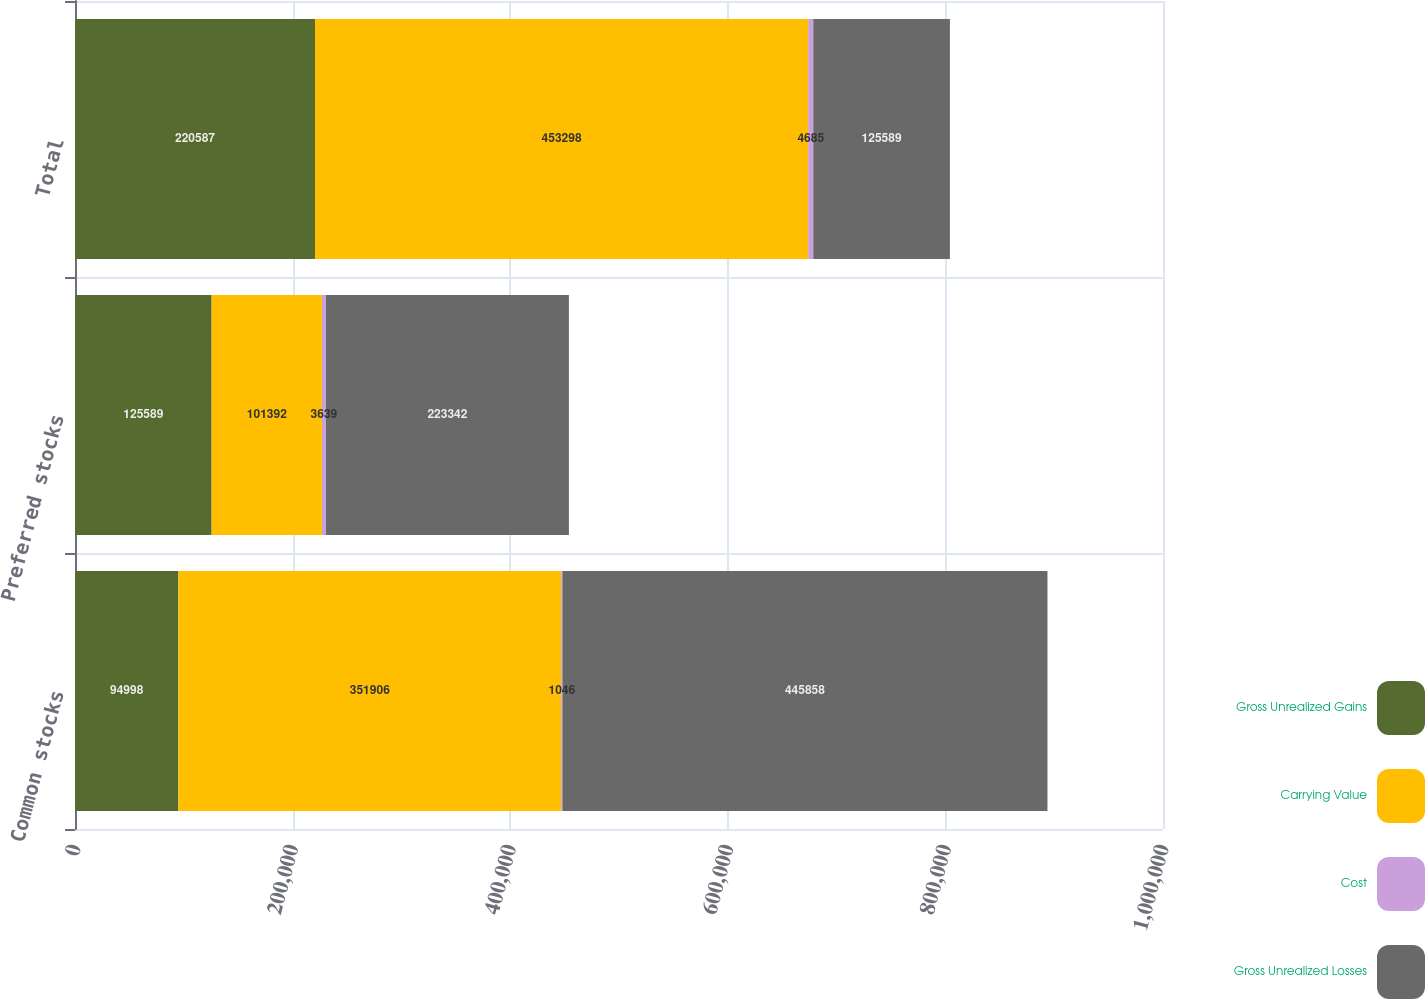Convert chart. <chart><loc_0><loc_0><loc_500><loc_500><stacked_bar_chart><ecel><fcel>Common stocks<fcel>Preferred stocks<fcel>Total<nl><fcel>Gross Unrealized Gains<fcel>94998<fcel>125589<fcel>220587<nl><fcel>Carrying Value<fcel>351906<fcel>101392<fcel>453298<nl><fcel>Cost<fcel>1046<fcel>3639<fcel>4685<nl><fcel>Gross Unrealized Losses<fcel>445858<fcel>223342<fcel>125589<nl></chart> 